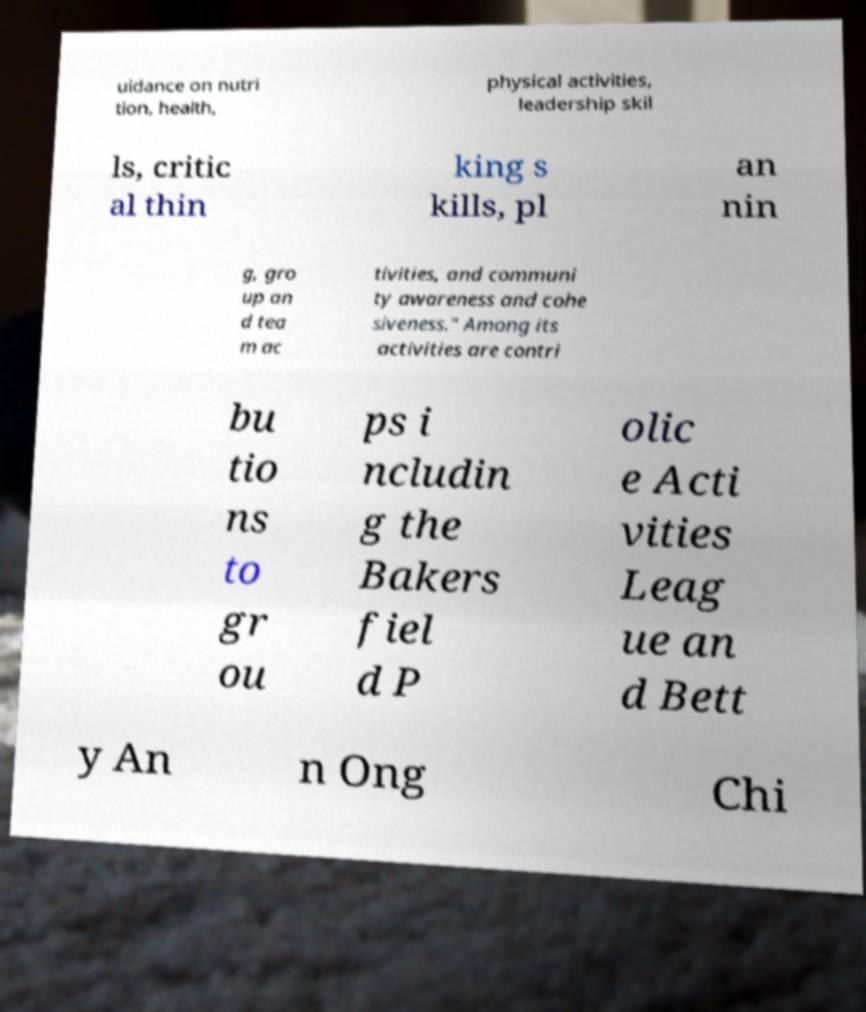Can you accurately transcribe the text from the provided image for me? uidance on nutri tion, health, physical activities, leadership skil ls, critic al thin king s kills, pl an nin g, gro up an d tea m ac tivities, and communi ty awareness and cohe siveness." Among its activities are contri bu tio ns to gr ou ps i ncludin g the Bakers fiel d P olic e Acti vities Leag ue an d Bett y An n Ong Chi 